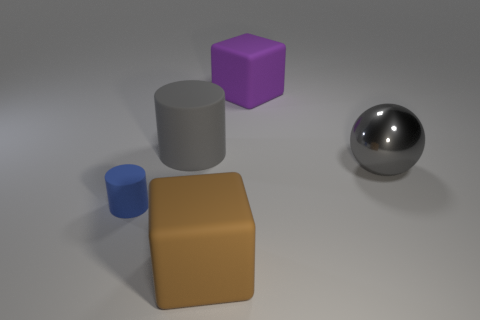Add 2 gray rubber cubes. How many objects exist? 7 Subtract all cylinders. How many objects are left? 3 Subtract all blue metal things. Subtract all big shiny objects. How many objects are left? 4 Add 2 shiny objects. How many shiny objects are left? 3 Add 3 tiny yellow metal things. How many tiny yellow metal things exist? 3 Subtract 0 yellow cylinders. How many objects are left? 5 